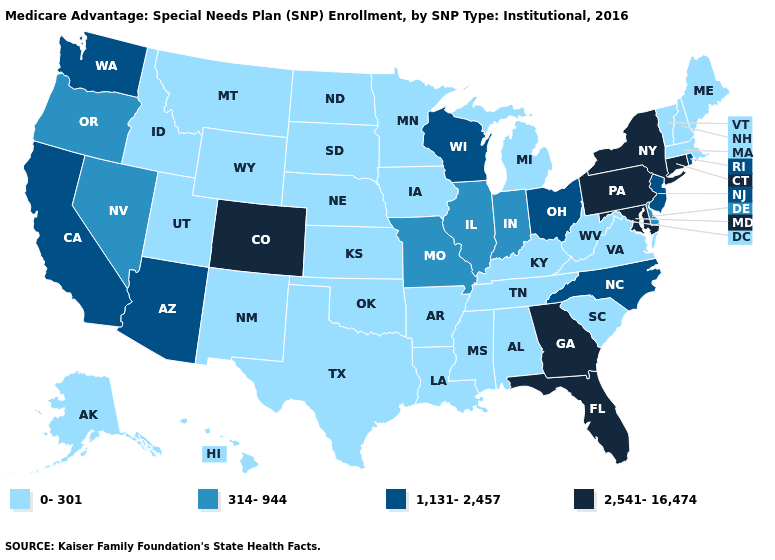Which states have the lowest value in the USA?
Write a very short answer. Alaska, Alabama, Arkansas, Hawaii, Iowa, Idaho, Kansas, Kentucky, Louisiana, Massachusetts, Maine, Michigan, Minnesota, Mississippi, Montana, North Dakota, Nebraska, New Hampshire, New Mexico, Oklahoma, South Carolina, South Dakota, Tennessee, Texas, Utah, Virginia, Vermont, West Virginia, Wyoming. Name the states that have a value in the range 0-301?
Answer briefly. Alaska, Alabama, Arkansas, Hawaii, Iowa, Idaho, Kansas, Kentucky, Louisiana, Massachusetts, Maine, Michigan, Minnesota, Mississippi, Montana, North Dakota, Nebraska, New Hampshire, New Mexico, Oklahoma, South Carolina, South Dakota, Tennessee, Texas, Utah, Virginia, Vermont, West Virginia, Wyoming. What is the value of South Dakota?
Answer briefly. 0-301. What is the value of Florida?
Keep it brief. 2,541-16,474. What is the value of New Mexico?
Keep it brief. 0-301. Which states have the lowest value in the Northeast?
Keep it brief. Massachusetts, Maine, New Hampshire, Vermont. What is the lowest value in states that border Utah?
Answer briefly. 0-301. What is the highest value in states that border Nebraska?
Be succinct. 2,541-16,474. Name the states that have a value in the range 1,131-2,457?
Answer briefly. Arizona, California, North Carolina, New Jersey, Ohio, Rhode Island, Washington, Wisconsin. What is the highest value in states that border Utah?
Give a very brief answer. 2,541-16,474. What is the lowest value in the South?
Concise answer only. 0-301. Among the states that border West Virginia , which have the lowest value?
Short answer required. Kentucky, Virginia. Name the states that have a value in the range 1,131-2,457?
Concise answer only. Arizona, California, North Carolina, New Jersey, Ohio, Rhode Island, Washington, Wisconsin. What is the value of Illinois?
Give a very brief answer. 314-944. 